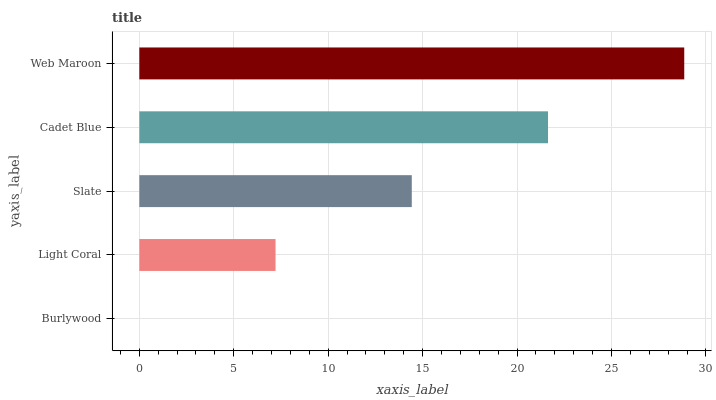Is Burlywood the minimum?
Answer yes or no. Yes. Is Web Maroon the maximum?
Answer yes or no. Yes. Is Light Coral the minimum?
Answer yes or no. No. Is Light Coral the maximum?
Answer yes or no. No. Is Light Coral greater than Burlywood?
Answer yes or no. Yes. Is Burlywood less than Light Coral?
Answer yes or no. Yes. Is Burlywood greater than Light Coral?
Answer yes or no. No. Is Light Coral less than Burlywood?
Answer yes or no. No. Is Slate the high median?
Answer yes or no. Yes. Is Slate the low median?
Answer yes or no. Yes. Is Web Maroon the high median?
Answer yes or no. No. Is Cadet Blue the low median?
Answer yes or no. No. 